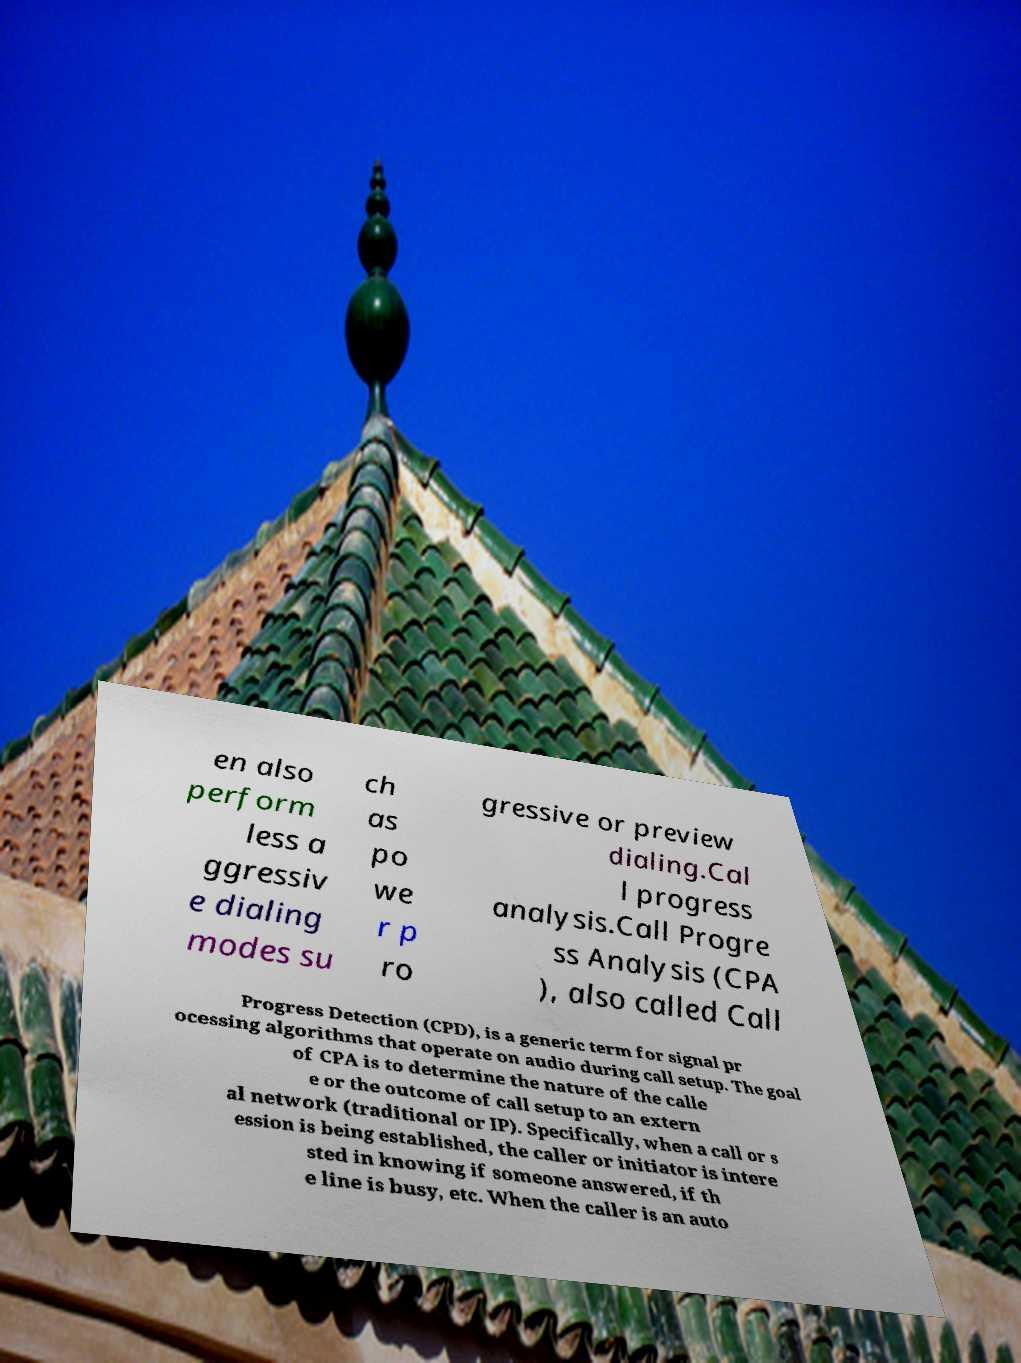Please identify and transcribe the text found in this image. en also perform less a ggressiv e dialing modes su ch as po we r p ro gressive or preview dialing.Cal l progress analysis.Call Progre ss Analysis (CPA ), also called Call Progress Detection (CPD), is a generic term for signal pr ocessing algorithms that operate on audio during call setup. The goal of CPA is to determine the nature of the calle e or the outcome of call setup to an extern al network (traditional or IP). Specifically, when a call or s ession is being established, the caller or initiator is intere sted in knowing if someone answered, if th e line is busy, etc. When the caller is an auto 